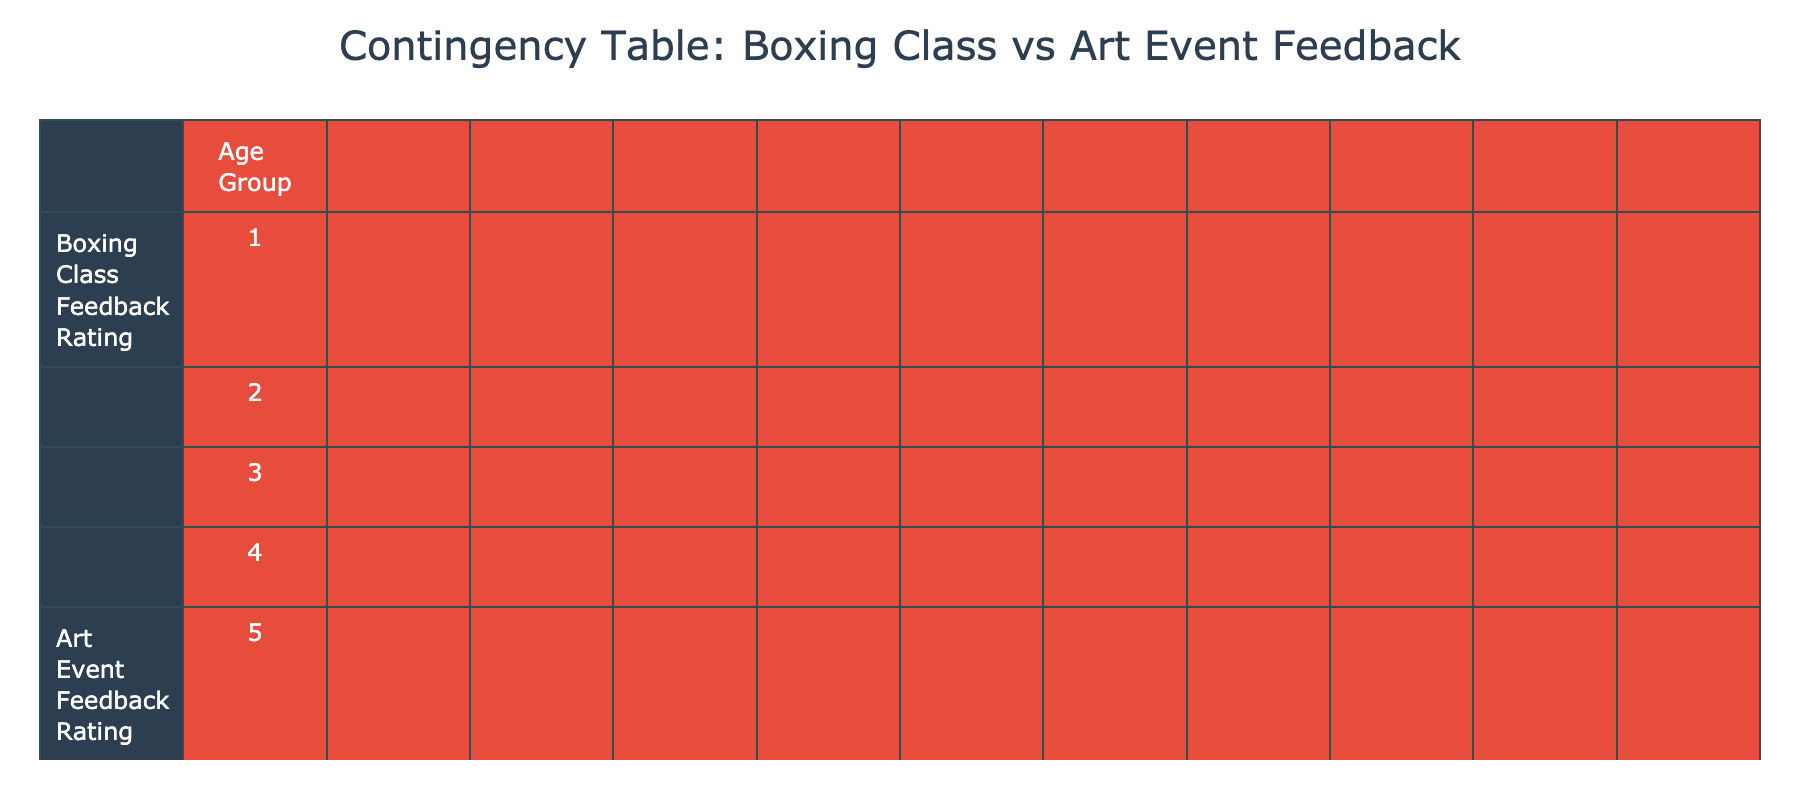What's the total number of feedback ratings provided for the age group 25-34? We can find this by counting the rows in the table corresponding to the 25-34 age group. There are 3 ratings for boxing classes and 3 ratings for art events, making a total of 3 + 3 = 6 ratings.
Answer: 6 In the 18-24 age group, how many participants rated the boxing class with a score of 5? Looking at the 18-24 age group row in the table, we find 1 rating of 5 for boxing classes.
Answer: 1 What is the average feedback rating for boxing classes across all age groups? To calculate the average, we sum all boxing class ratings (4+5+3+5+4+3+4+4+5+3+4+2+2+3+1 = 57) and divide by the total number of ratings (15). The average is thus 57 / 15 = 3.8.
Answer: 3.8 Is it true that at least one participant in the 35-44 age group rated the art event as a 5? Checking the table, we see that there is one participant from the 35-44 group who rated the art event as a 5. Therefore, the statement is true.
Answer: Yes What is the difference between the total feedback ratings for boxing classes (1-5) and art events (1-5) from participants aged 45-54? For 45-54, boxing class ratings sum up to (3 + 4 + 2 = 9) and art event ratings add up to (3 + 5 + 2 = 10). The difference is 10 - 9 = 1.
Answer: 1 How many participants aged 55+ rated both boxing classes and art events with a score of 3? For the 55+ age group, one participant rated boxing classes as 3 and another rated art events as 3. Therefore, there are 2 participants.
Answer: 2 What age group has the highest average feedback rating for art events? We calculate the average for each age group: 18-24 has (5+4+3)/3 = 4, 25-34 has (5+4+4)/3 = 4.33, 35-44 has (3+4+2)/3 = 3, 45-54 has (3+5+2)/3 = 3.33, 55+ has (3+4+2)/3 = 3. The highest average is thus for the 25-34 age group at 4.33.
Answer: 25-34 Which feedback rating received by boxing classes had the least number of participants? Looking at the table, the rating of 1 has only 1 participant from the 55+ age group that rated boxing classes as 1. Therefore, that's the least number of participants.
Answer: 1 In total, how many feedback ratings of the art event received a score of 2? By counting in the table, we see there are 2 ratings of 2 for the art event (from the 45-54 and 55+ age groups). Thus, the total is 2.
Answer: 2 